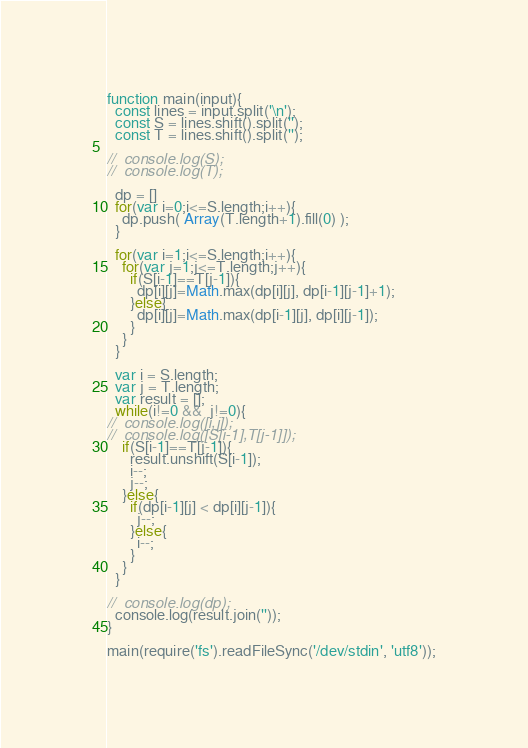<code> <loc_0><loc_0><loc_500><loc_500><_JavaScript_>function main(input){
  const lines = input.split('\n');
  const S = lines.shift().split('');
  const T = lines.shift().split('');

//  console.log(S);
//  console.log(T);

  dp = []
  for(var i=0;i<=S.length;i++){
    dp.push( Array(T.length+1).fill(0) );
  }

  for(var i=1;i<=S.length;i++){
    for(var j=1;j<=T.length;j++){
      if(S[i-1]==T[j-1]){
        dp[i][j]=Math.max(dp[i][j], dp[i-1][j-1]+1);
      }else{
        dp[i][j]=Math.max(dp[i-1][j], dp[i][j-1]);
      }
    }
  }

  var i = S.length;
  var j = T.length;
  var result = [];
  while(i!=0 &&  j!=0){
//  console.log([i,j]);
//  console.log([S[i-1],T[j-1]]);
    if(S[i-1]==T[j-1]){
      result.unshift(S[i-1]);
      i--;
      j--;
    }else{
      if(dp[i-1][j] < dp[i][j-1]){
        j--;
      }else{
        i--;
      }
    }
  }

//  console.log(dp);
  console.log(result.join(''));
}

main(require('fs').readFileSync('/dev/stdin', 'utf8'));
</code> 